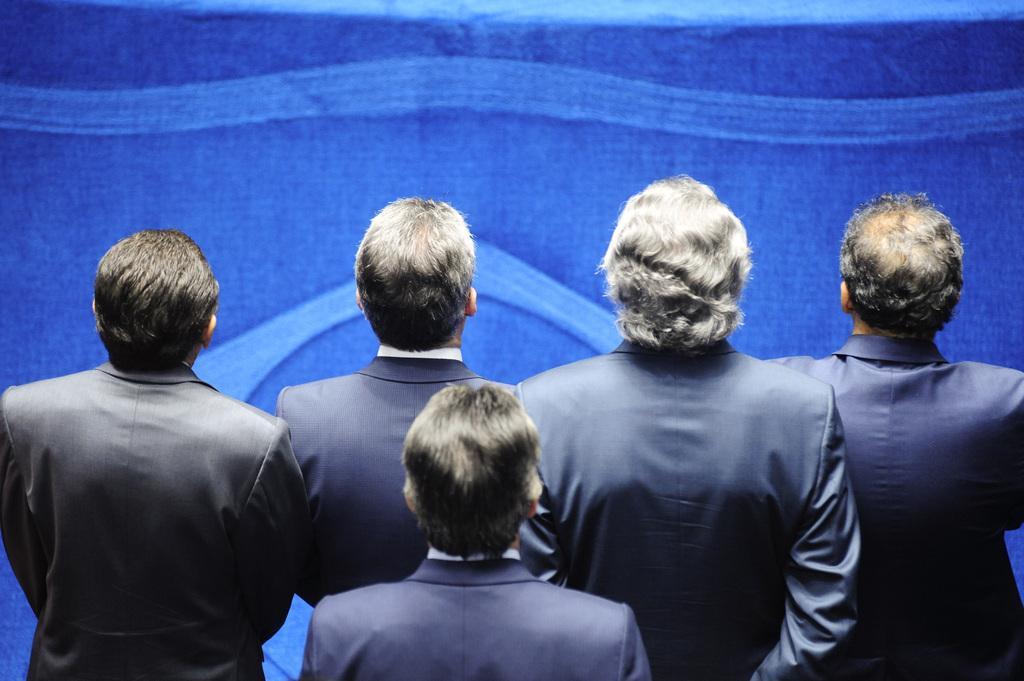Describe this image in one or two sentences. In this image at the bottom there are a group of people who are standing, and in the background there is a wall. 